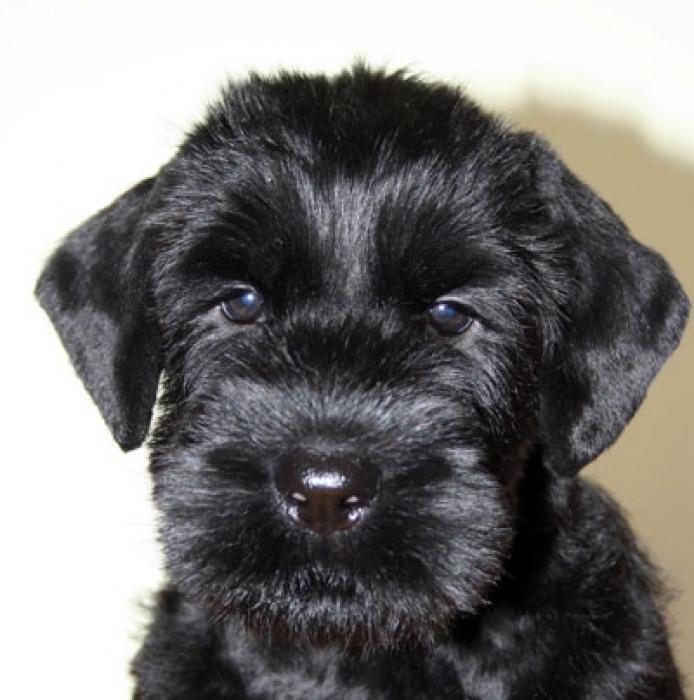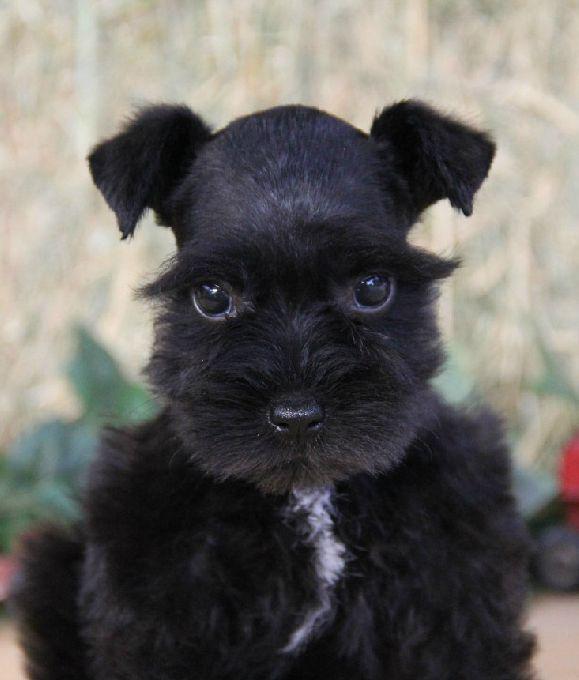The first image is the image on the left, the second image is the image on the right. Considering the images on both sides, is "Each image contains a camera-facing schnauzer with a solid-black face, and no image shows a dog in a reclining pose." valid? Answer yes or no. Yes. The first image is the image on the left, the second image is the image on the right. For the images shown, is this caption "The puppy on the right has a white streak on its chest." true? Answer yes or no. Yes. 